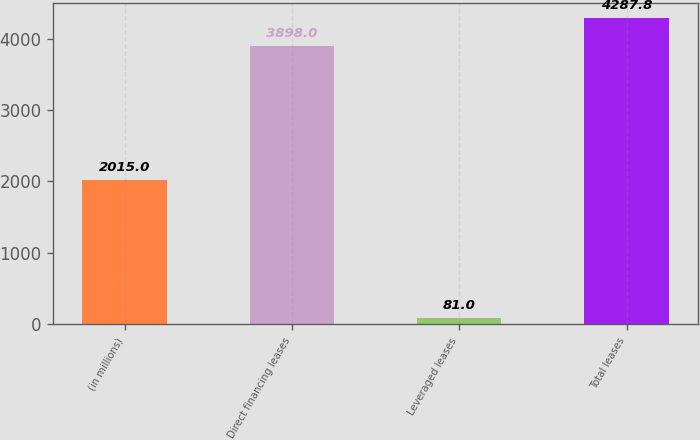Convert chart to OTSL. <chart><loc_0><loc_0><loc_500><loc_500><bar_chart><fcel>(in millions)<fcel>Direct financing leases<fcel>Leveraged leases<fcel>Total leases<nl><fcel>2015<fcel>3898<fcel>81<fcel>4287.8<nl></chart> 